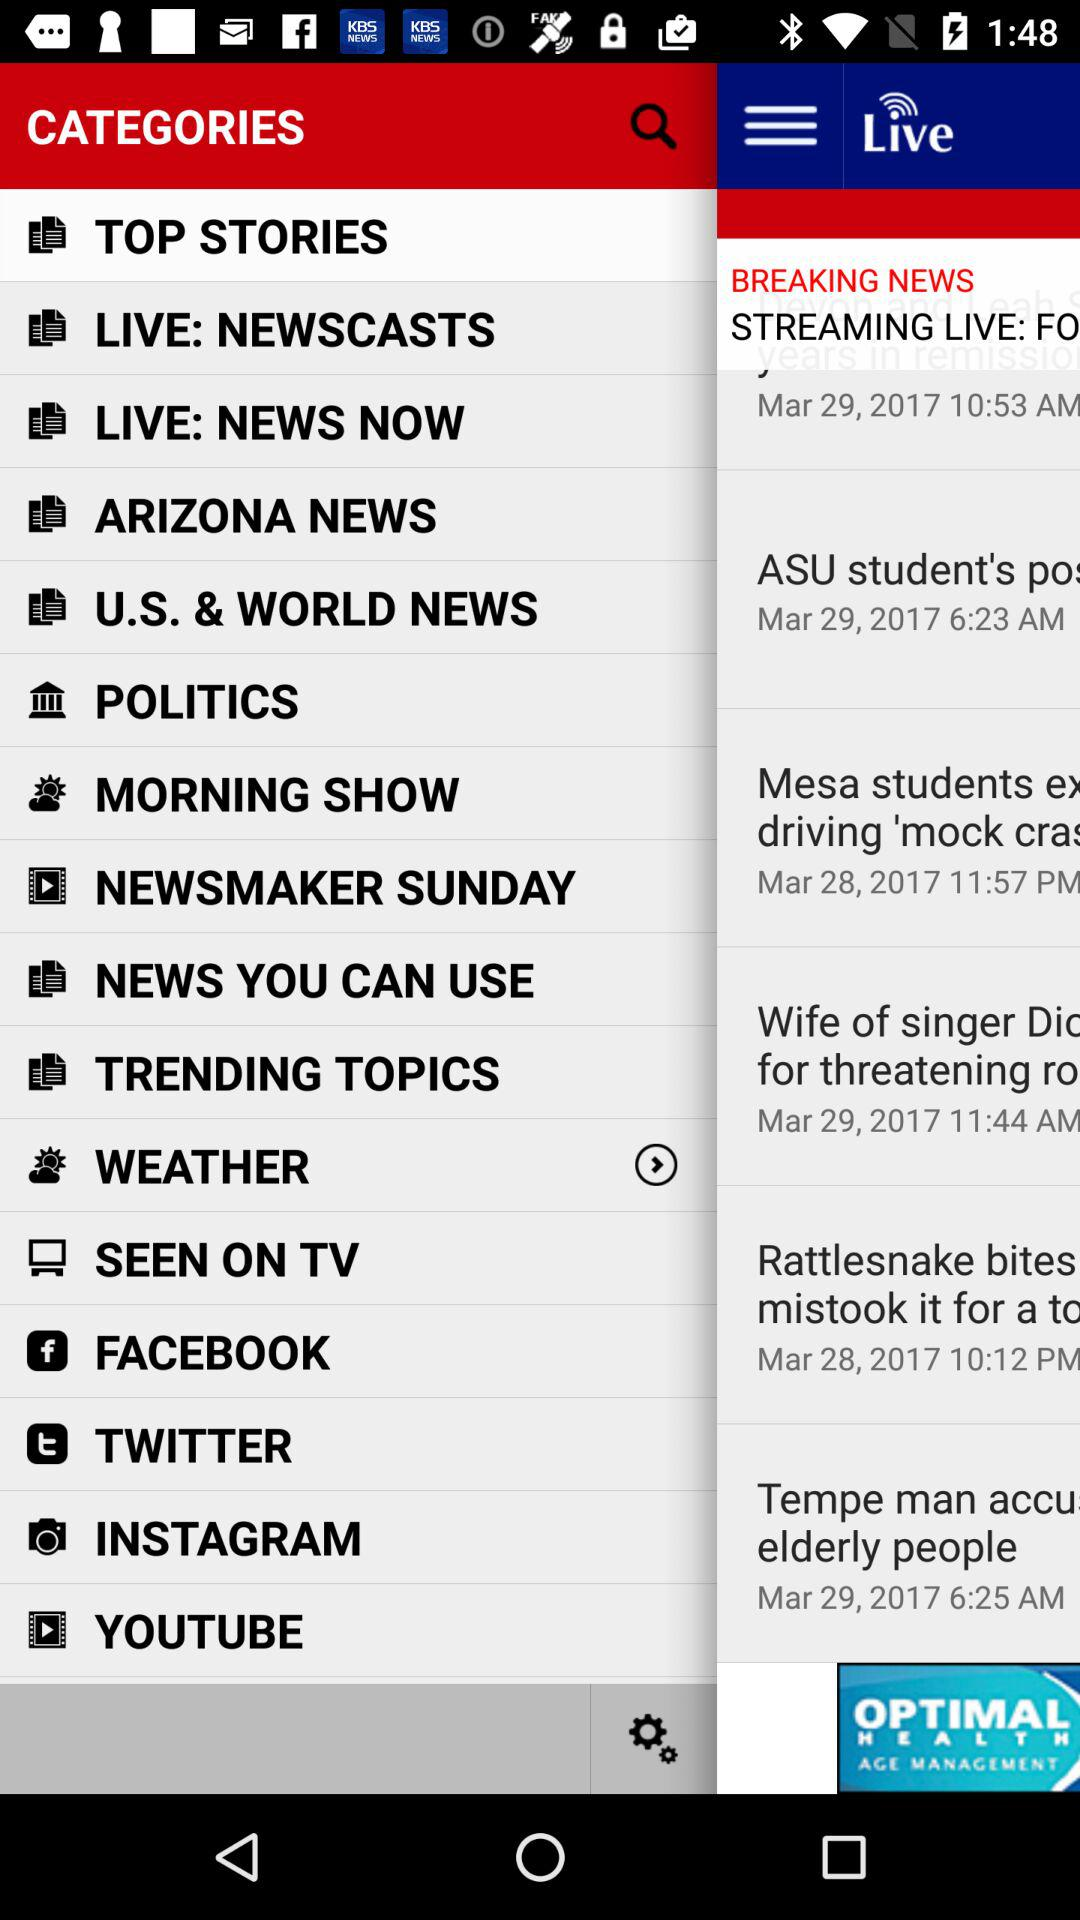What is the date and time?
When the provided information is insufficient, respond with <no answer>. <no answer> 